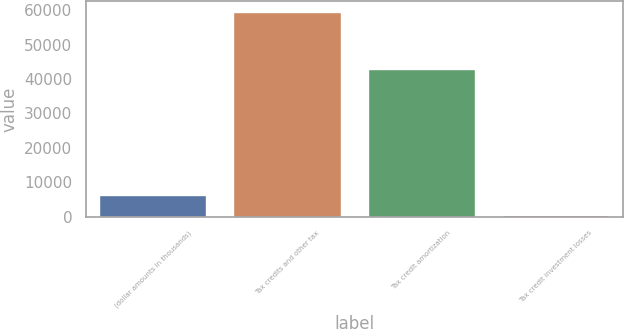Convert chart to OTSL. <chart><loc_0><loc_0><loc_500><loc_500><bar_chart><fcel>(dollar amounts in thousands)<fcel>Tax credits and other tax<fcel>Tax credit amortization<fcel>Tax credit investment losses<nl><fcel>6280.9<fcel>59614<fcel>42951<fcel>355<nl></chart> 